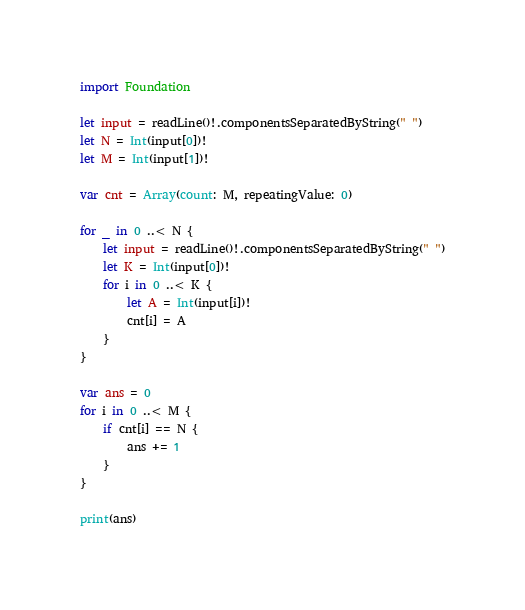<code> <loc_0><loc_0><loc_500><loc_500><_Swift_>import Foundation

let input = readLine()!.componentsSeparatedByString(" ")
let N = Int(input[0])!
let M = Int(input[1])!

var cnt = Array(count: M, repeatingValue: 0)

for _ in 0 ..< N {
    let input = readLine()!.componentsSeparatedByString(" ")
    let K = Int(input[0])!
    for i in 0 ..< K {
        let A = Int(input[i])!
        cnt[i] = A
    }
}

var ans = 0
for i in 0 ..< M {
    if cnt[i] == N {
        ans += 1
    }
}

print(ans)
</code> 